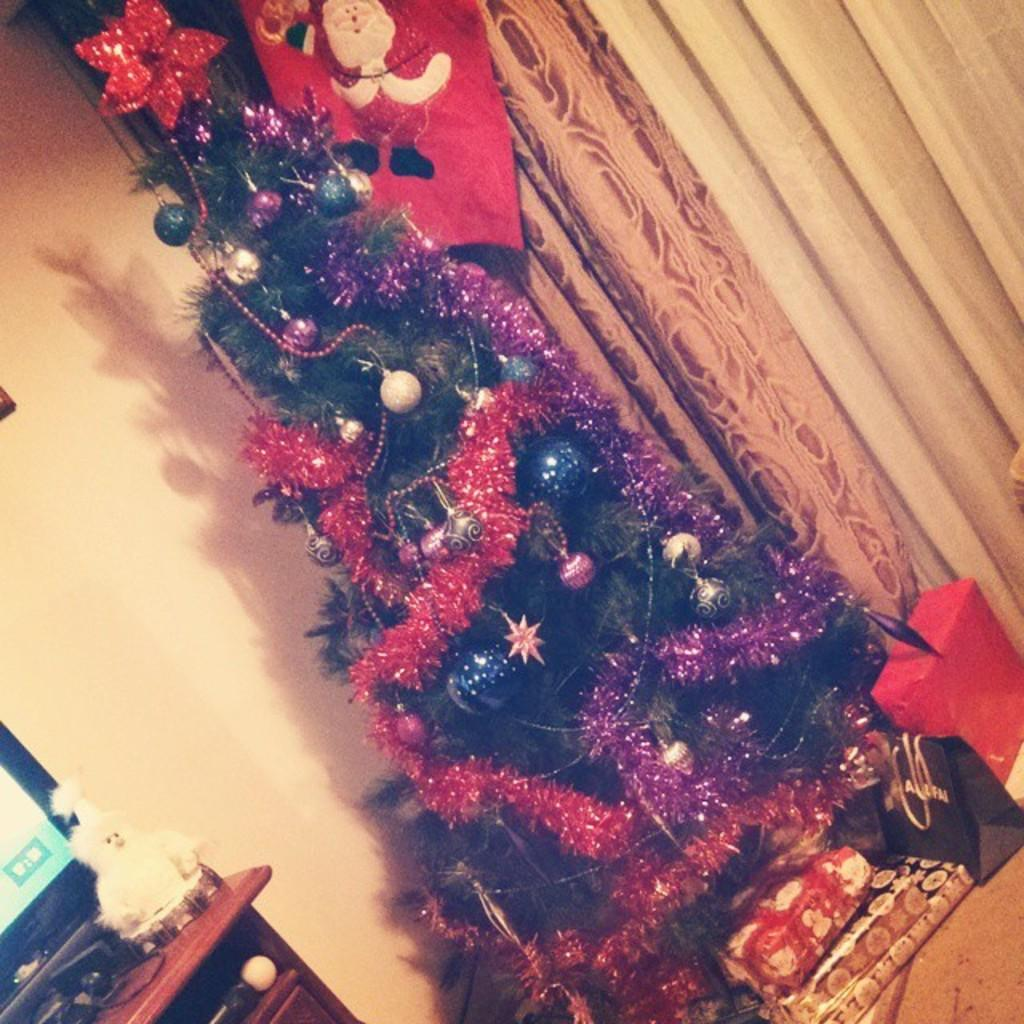What is the main subject of the image? There is a decorated Christmas tree in the image. What else can be seen in the image besides the Christmas tree? There are gifts, carry bags, a table, a screen, a toy, and curtains in the image. Where is the table located in the image? The table is on the left side of the image. What is on the table? There is a screen and a toy on the table. What type of curtains are visible in the image? The curtains are at the back of the image. What type of skirt is hanging on the toy in the image? There is no skirt present in the image; the toy is not wearing any clothing. 